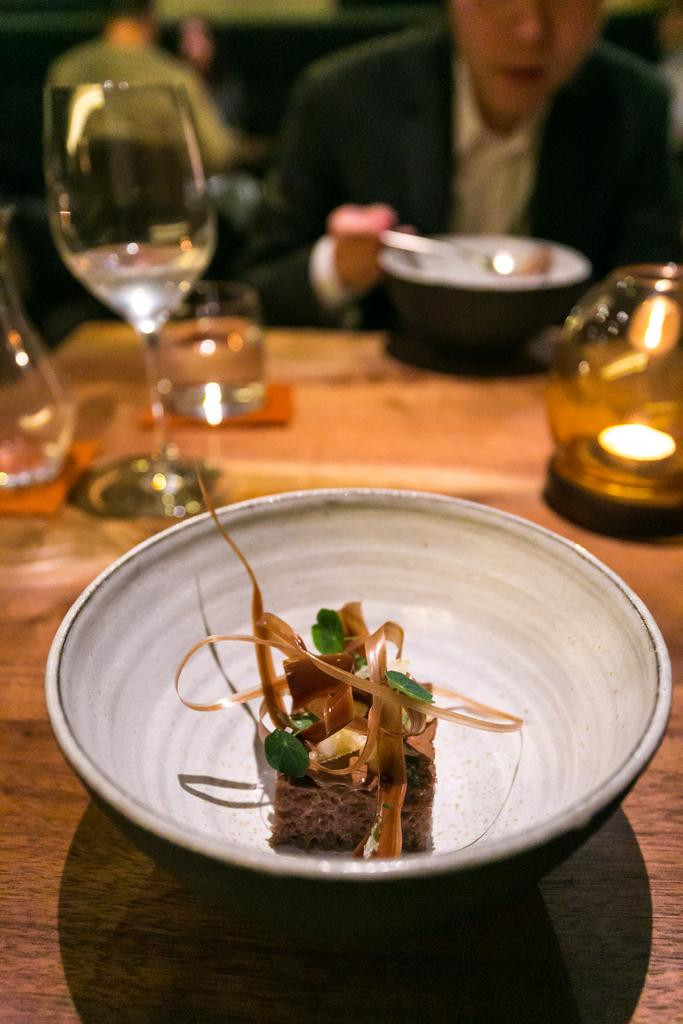What is on the plate that is visible in the image? There is food on a white plate in the image. Where is the plate located in the image? The plate is placed on a dining table. What is the man in the image doing? The man is sitting and eating the food in the image. What type of flame can be seen coming from the man's head in the image? There is no flame present in the image; the man is simply sitting and eating food. 